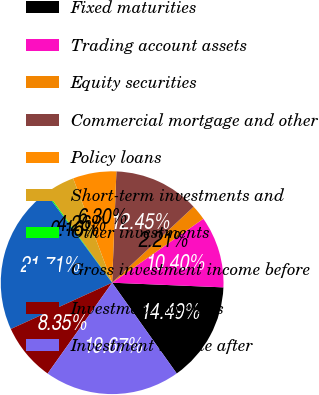Convert chart. <chart><loc_0><loc_0><loc_500><loc_500><pie_chart><fcel>Fixed maturities<fcel>Trading account assets<fcel>Equity securities<fcel>Commercial mortgage and other<fcel>Policy loans<fcel>Short-term investments and<fcel>Other investments<fcel>Gross investment income before<fcel>Investment expenses<fcel>Investment income after<nl><fcel>14.49%<fcel>10.4%<fcel>2.21%<fcel>12.45%<fcel>6.3%<fcel>4.26%<fcel>0.16%<fcel>21.71%<fcel>8.35%<fcel>19.67%<nl></chart> 